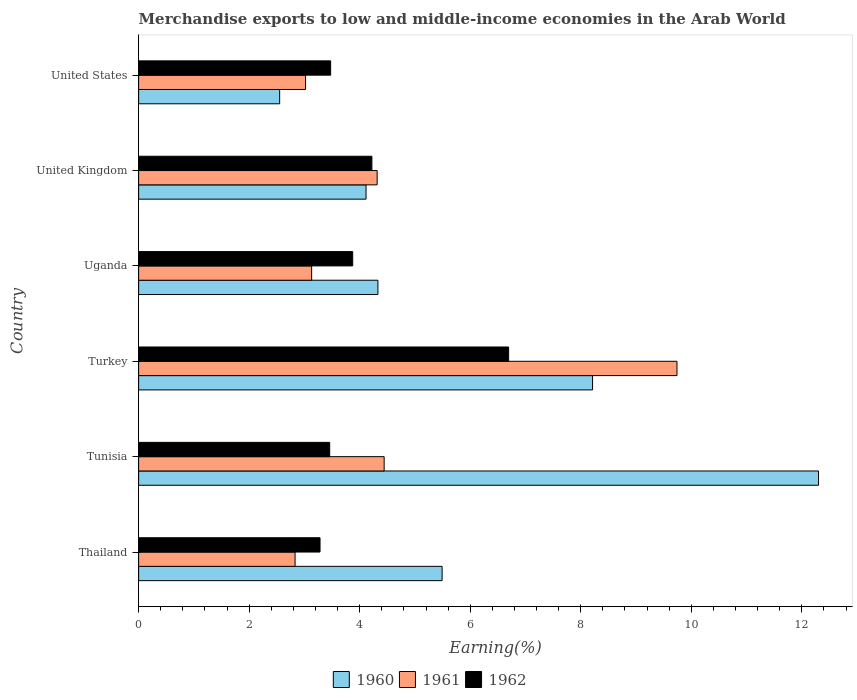How many bars are there on the 1st tick from the bottom?
Offer a very short reply. 3. What is the label of the 1st group of bars from the top?
Give a very brief answer. United States. In how many cases, is the number of bars for a given country not equal to the number of legend labels?
Make the answer very short. 0. What is the percentage of amount earned from merchandise exports in 1961 in United States?
Ensure brevity in your answer.  3.02. Across all countries, what is the maximum percentage of amount earned from merchandise exports in 1962?
Make the answer very short. 6.69. Across all countries, what is the minimum percentage of amount earned from merchandise exports in 1962?
Keep it short and to the point. 3.28. In which country was the percentage of amount earned from merchandise exports in 1960 maximum?
Your response must be concise. Tunisia. In which country was the percentage of amount earned from merchandise exports in 1960 minimum?
Provide a short and direct response. United States. What is the total percentage of amount earned from merchandise exports in 1960 in the graph?
Provide a short and direct response. 37. What is the difference between the percentage of amount earned from merchandise exports in 1961 in Tunisia and that in Turkey?
Give a very brief answer. -5.3. What is the difference between the percentage of amount earned from merchandise exports in 1962 in United Kingdom and the percentage of amount earned from merchandise exports in 1961 in United States?
Offer a very short reply. 1.2. What is the average percentage of amount earned from merchandise exports in 1961 per country?
Your response must be concise. 4.58. What is the difference between the percentage of amount earned from merchandise exports in 1962 and percentage of amount earned from merchandise exports in 1961 in United States?
Provide a succinct answer. 0.45. What is the ratio of the percentage of amount earned from merchandise exports in 1961 in Thailand to that in Turkey?
Provide a succinct answer. 0.29. Is the difference between the percentage of amount earned from merchandise exports in 1962 in United Kingdom and United States greater than the difference between the percentage of amount earned from merchandise exports in 1961 in United Kingdom and United States?
Make the answer very short. No. What is the difference between the highest and the second highest percentage of amount earned from merchandise exports in 1962?
Provide a succinct answer. 2.47. What is the difference between the highest and the lowest percentage of amount earned from merchandise exports in 1960?
Offer a terse response. 9.75. Is the sum of the percentage of amount earned from merchandise exports in 1961 in Turkey and United States greater than the maximum percentage of amount earned from merchandise exports in 1962 across all countries?
Keep it short and to the point. Yes. How many bars are there?
Keep it short and to the point. 18. Are all the bars in the graph horizontal?
Offer a terse response. Yes. How many countries are there in the graph?
Offer a very short reply. 6. Are the values on the major ticks of X-axis written in scientific E-notation?
Make the answer very short. No. Where does the legend appear in the graph?
Your response must be concise. Bottom center. How many legend labels are there?
Your response must be concise. 3. How are the legend labels stacked?
Make the answer very short. Horizontal. What is the title of the graph?
Offer a terse response. Merchandise exports to low and middle-income economies in the Arab World. Does "1979" appear as one of the legend labels in the graph?
Give a very brief answer. No. What is the label or title of the X-axis?
Provide a succinct answer. Earning(%). What is the label or title of the Y-axis?
Your response must be concise. Country. What is the Earning(%) in 1960 in Thailand?
Ensure brevity in your answer.  5.49. What is the Earning(%) in 1961 in Thailand?
Make the answer very short. 2.83. What is the Earning(%) in 1962 in Thailand?
Ensure brevity in your answer.  3.28. What is the Earning(%) of 1960 in Tunisia?
Give a very brief answer. 12.3. What is the Earning(%) in 1961 in Tunisia?
Ensure brevity in your answer.  4.44. What is the Earning(%) in 1962 in Tunisia?
Your answer should be very brief. 3.46. What is the Earning(%) in 1960 in Turkey?
Your response must be concise. 8.21. What is the Earning(%) in 1961 in Turkey?
Your answer should be very brief. 9.74. What is the Earning(%) of 1962 in Turkey?
Your answer should be very brief. 6.69. What is the Earning(%) of 1960 in Uganda?
Offer a terse response. 4.33. What is the Earning(%) in 1961 in Uganda?
Make the answer very short. 3.13. What is the Earning(%) in 1962 in Uganda?
Your answer should be very brief. 3.87. What is the Earning(%) in 1960 in United Kingdom?
Offer a terse response. 4.11. What is the Earning(%) in 1961 in United Kingdom?
Offer a very short reply. 4.32. What is the Earning(%) of 1962 in United Kingdom?
Offer a terse response. 4.22. What is the Earning(%) in 1960 in United States?
Offer a terse response. 2.55. What is the Earning(%) of 1961 in United States?
Your answer should be compact. 3.02. What is the Earning(%) of 1962 in United States?
Keep it short and to the point. 3.47. Across all countries, what is the maximum Earning(%) of 1960?
Your response must be concise. 12.3. Across all countries, what is the maximum Earning(%) in 1961?
Offer a terse response. 9.74. Across all countries, what is the maximum Earning(%) of 1962?
Ensure brevity in your answer.  6.69. Across all countries, what is the minimum Earning(%) of 1960?
Provide a short and direct response. 2.55. Across all countries, what is the minimum Earning(%) in 1961?
Your response must be concise. 2.83. Across all countries, what is the minimum Earning(%) in 1962?
Offer a very short reply. 3.28. What is the total Earning(%) of 1960 in the graph?
Make the answer very short. 37. What is the total Earning(%) in 1961 in the graph?
Make the answer very short. 27.48. What is the total Earning(%) in 1962 in the graph?
Offer a terse response. 25. What is the difference between the Earning(%) of 1960 in Thailand and that in Tunisia?
Offer a very short reply. -6.81. What is the difference between the Earning(%) of 1961 in Thailand and that in Tunisia?
Your answer should be compact. -1.61. What is the difference between the Earning(%) of 1962 in Thailand and that in Tunisia?
Make the answer very short. -0.18. What is the difference between the Earning(%) in 1960 in Thailand and that in Turkey?
Your answer should be compact. -2.72. What is the difference between the Earning(%) in 1961 in Thailand and that in Turkey?
Keep it short and to the point. -6.91. What is the difference between the Earning(%) in 1962 in Thailand and that in Turkey?
Give a very brief answer. -3.41. What is the difference between the Earning(%) in 1960 in Thailand and that in Uganda?
Your response must be concise. 1.16. What is the difference between the Earning(%) of 1961 in Thailand and that in Uganda?
Provide a short and direct response. -0.3. What is the difference between the Earning(%) in 1962 in Thailand and that in Uganda?
Your answer should be compact. -0.59. What is the difference between the Earning(%) in 1960 in Thailand and that in United Kingdom?
Make the answer very short. 1.38. What is the difference between the Earning(%) in 1961 in Thailand and that in United Kingdom?
Offer a very short reply. -1.49. What is the difference between the Earning(%) in 1962 in Thailand and that in United Kingdom?
Provide a short and direct response. -0.94. What is the difference between the Earning(%) of 1960 in Thailand and that in United States?
Keep it short and to the point. 2.94. What is the difference between the Earning(%) in 1961 in Thailand and that in United States?
Ensure brevity in your answer.  -0.19. What is the difference between the Earning(%) of 1962 in Thailand and that in United States?
Your answer should be very brief. -0.19. What is the difference between the Earning(%) of 1960 in Tunisia and that in Turkey?
Keep it short and to the point. 4.09. What is the difference between the Earning(%) of 1961 in Tunisia and that in Turkey?
Provide a succinct answer. -5.3. What is the difference between the Earning(%) in 1962 in Tunisia and that in Turkey?
Offer a terse response. -3.24. What is the difference between the Earning(%) of 1960 in Tunisia and that in Uganda?
Make the answer very short. 7.97. What is the difference between the Earning(%) of 1961 in Tunisia and that in Uganda?
Keep it short and to the point. 1.31. What is the difference between the Earning(%) in 1962 in Tunisia and that in Uganda?
Offer a very short reply. -0.42. What is the difference between the Earning(%) in 1960 in Tunisia and that in United Kingdom?
Provide a succinct answer. 8.19. What is the difference between the Earning(%) in 1961 in Tunisia and that in United Kingdom?
Provide a short and direct response. 0.13. What is the difference between the Earning(%) of 1962 in Tunisia and that in United Kingdom?
Ensure brevity in your answer.  -0.76. What is the difference between the Earning(%) of 1960 in Tunisia and that in United States?
Provide a succinct answer. 9.75. What is the difference between the Earning(%) of 1961 in Tunisia and that in United States?
Make the answer very short. 1.42. What is the difference between the Earning(%) of 1962 in Tunisia and that in United States?
Provide a short and direct response. -0.02. What is the difference between the Earning(%) in 1960 in Turkey and that in Uganda?
Your answer should be compact. 3.88. What is the difference between the Earning(%) of 1961 in Turkey and that in Uganda?
Ensure brevity in your answer.  6.61. What is the difference between the Earning(%) in 1962 in Turkey and that in Uganda?
Provide a short and direct response. 2.82. What is the difference between the Earning(%) in 1960 in Turkey and that in United Kingdom?
Keep it short and to the point. 4.1. What is the difference between the Earning(%) of 1961 in Turkey and that in United Kingdom?
Keep it short and to the point. 5.42. What is the difference between the Earning(%) in 1962 in Turkey and that in United Kingdom?
Offer a very short reply. 2.47. What is the difference between the Earning(%) of 1960 in Turkey and that in United States?
Make the answer very short. 5.66. What is the difference between the Earning(%) of 1961 in Turkey and that in United States?
Give a very brief answer. 6.72. What is the difference between the Earning(%) of 1962 in Turkey and that in United States?
Make the answer very short. 3.22. What is the difference between the Earning(%) in 1960 in Uganda and that in United Kingdom?
Provide a short and direct response. 0.21. What is the difference between the Earning(%) of 1961 in Uganda and that in United Kingdom?
Your answer should be compact. -1.19. What is the difference between the Earning(%) of 1962 in Uganda and that in United Kingdom?
Provide a short and direct response. -0.35. What is the difference between the Earning(%) in 1960 in Uganda and that in United States?
Ensure brevity in your answer.  1.78. What is the difference between the Earning(%) of 1961 in Uganda and that in United States?
Your answer should be very brief. 0.11. What is the difference between the Earning(%) in 1962 in Uganda and that in United States?
Provide a short and direct response. 0.4. What is the difference between the Earning(%) in 1960 in United Kingdom and that in United States?
Your answer should be compact. 1.56. What is the difference between the Earning(%) of 1961 in United Kingdom and that in United States?
Ensure brevity in your answer.  1.3. What is the difference between the Earning(%) of 1962 in United Kingdom and that in United States?
Give a very brief answer. 0.75. What is the difference between the Earning(%) in 1960 in Thailand and the Earning(%) in 1961 in Tunisia?
Provide a succinct answer. 1.05. What is the difference between the Earning(%) of 1960 in Thailand and the Earning(%) of 1962 in Tunisia?
Offer a very short reply. 2.03. What is the difference between the Earning(%) of 1961 in Thailand and the Earning(%) of 1962 in Tunisia?
Keep it short and to the point. -0.63. What is the difference between the Earning(%) in 1960 in Thailand and the Earning(%) in 1961 in Turkey?
Keep it short and to the point. -4.25. What is the difference between the Earning(%) in 1960 in Thailand and the Earning(%) in 1962 in Turkey?
Give a very brief answer. -1.2. What is the difference between the Earning(%) in 1961 in Thailand and the Earning(%) in 1962 in Turkey?
Keep it short and to the point. -3.86. What is the difference between the Earning(%) of 1960 in Thailand and the Earning(%) of 1961 in Uganda?
Give a very brief answer. 2.36. What is the difference between the Earning(%) of 1960 in Thailand and the Earning(%) of 1962 in Uganda?
Your response must be concise. 1.62. What is the difference between the Earning(%) of 1961 in Thailand and the Earning(%) of 1962 in Uganda?
Keep it short and to the point. -1.04. What is the difference between the Earning(%) in 1960 in Thailand and the Earning(%) in 1961 in United Kingdom?
Your answer should be very brief. 1.18. What is the difference between the Earning(%) in 1960 in Thailand and the Earning(%) in 1962 in United Kingdom?
Your answer should be compact. 1.27. What is the difference between the Earning(%) in 1961 in Thailand and the Earning(%) in 1962 in United Kingdom?
Keep it short and to the point. -1.39. What is the difference between the Earning(%) of 1960 in Thailand and the Earning(%) of 1961 in United States?
Give a very brief answer. 2.47. What is the difference between the Earning(%) of 1960 in Thailand and the Earning(%) of 1962 in United States?
Make the answer very short. 2.02. What is the difference between the Earning(%) of 1961 in Thailand and the Earning(%) of 1962 in United States?
Ensure brevity in your answer.  -0.64. What is the difference between the Earning(%) in 1960 in Tunisia and the Earning(%) in 1961 in Turkey?
Offer a terse response. 2.56. What is the difference between the Earning(%) in 1960 in Tunisia and the Earning(%) in 1962 in Turkey?
Your answer should be very brief. 5.61. What is the difference between the Earning(%) in 1961 in Tunisia and the Earning(%) in 1962 in Turkey?
Ensure brevity in your answer.  -2.25. What is the difference between the Earning(%) in 1960 in Tunisia and the Earning(%) in 1961 in Uganda?
Provide a short and direct response. 9.17. What is the difference between the Earning(%) of 1960 in Tunisia and the Earning(%) of 1962 in Uganda?
Make the answer very short. 8.43. What is the difference between the Earning(%) of 1961 in Tunisia and the Earning(%) of 1962 in Uganda?
Ensure brevity in your answer.  0.57. What is the difference between the Earning(%) of 1960 in Tunisia and the Earning(%) of 1961 in United Kingdom?
Make the answer very short. 7.99. What is the difference between the Earning(%) of 1960 in Tunisia and the Earning(%) of 1962 in United Kingdom?
Give a very brief answer. 8.08. What is the difference between the Earning(%) of 1961 in Tunisia and the Earning(%) of 1962 in United Kingdom?
Your answer should be compact. 0.22. What is the difference between the Earning(%) of 1960 in Tunisia and the Earning(%) of 1961 in United States?
Make the answer very short. 9.28. What is the difference between the Earning(%) of 1960 in Tunisia and the Earning(%) of 1962 in United States?
Ensure brevity in your answer.  8.83. What is the difference between the Earning(%) in 1961 in Tunisia and the Earning(%) in 1962 in United States?
Keep it short and to the point. 0.97. What is the difference between the Earning(%) of 1960 in Turkey and the Earning(%) of 1961 in Uganda?
Provide a succinct answer. 5.08. What is the difference between the Earning(%) in 1960 in Turkey and the Earning(%) in 1962 in Uganda?
Offer a terse response. 4.34. What is the difference between the Earning(%) in 1961 in Turkey and the Earning(%) in 1962 in Uganda?
Provide a succinct answer. 5.87. What is the difference between the Earning(%) of 1960 in Turkey and the Earning(%) of 1961 in United Kingdom?
Provide a succinct answer. 3.9. What is the difference between the Earning(%) of 1960 in Turkey and the Earning(%) of 1962 in United Kingdom?
Offer a very short reply. 3.99. What is the difference between the Earning(%) in 1961 in Turkey and the Earning(%) in 1962 in United Kingdom?
Give a very brief answer. 5.52. What is the difference between the Earning(%) in 1960 in Turkey and the Earning(%) in 1961 in United States?
Your answer should be very brief. 5.19. What is the difference between the Earning(%) in 1960 in Turkey and the Earning(%) in 1962 in United States?
Provide a short and direct response. 4.74. What is the difference between the Earning(%) in 1961 in Turkey and the Earning(%) in 1962 in United States?
Keep it short and to the point. 6.27. What is the difference between the Earning(%) of 1960 in Uganda and the Earning(%) of 1961 in United Kingdom?
Your response must be concise. 0.01. What is the difference between the Earning(%) in 1960 in Uganda and the Earning(%) in 1962 in United Kingdom?
Your answer should be compact. 0.11. What is the difference between the Earning(%) in 1961 in Uganda and the Earning(%) in 1962 in United Kingdom?
Make the answer very short. -1.09. What is the difference between the Earning(%) of 1960 in Uganda and the Earning(%) of 1961 in United States?
Your response must be concise. 1.31. What is the difference between the Earning(%) in 1960 in Uganda and the Earning(%) in 1962 in United States?
Offer a terse response. 0.86. What is the difference between the Earning(%) of 1961 in Uganda and the Earning(%) of 1962 in United States?
Ensure brevity in your answer.  -0.34. What is the difference between the Earning(%) in 1960 in United Kingdom and the Earning(%) in 1961 in United States?
Your answer should be very brief. 1.09. What is the difference between the Earning(%) of 1960 in United Kingdom and the Earning(%) of 1962 in United States?
Provide a short and direct response. 0.64. What is the difference between the Earning(%) of 1961 in United Kingdom and the Earning(%) of 1962 in United States?
Make the answer very short. 0.84. What is the average Earning(%) in 1960 per country?
Offer a very short reply. 6.17. What is the average Earning(%) in 1961 per country?
Provide a short and direct response. 4.58. What is the average Earning(%) of 1962 per country?
Your answer should be compact. 4.17. What is the difference between the Earning(%) in 1960 and Earning(%) in 1961 in Thailand?
Provide a short and direct response. 2.66. What is the difference between the Earning(%) of 1960 and Earning(%) of 1962 in Thailand?
Offer a very short reply. 2.21. What is the difference between the Earning(%) in 1961 and Earning(%) in 1962 in Thailand?
Provide a short and direct response. -0.45. What is the difference between the Earning(%) of 1960 and Earning(%) of 1961 in Tunisia?
Make the answer very short. 7.86. What is the difference between the Earning(%) in 1960 and Earning(%) in 1962 in Tunisia?
Ensure brevity in your answer.  8.84. What is the difference between the Earning(%) in 1961 and Earning(%) in 1962 in Tunisia?
Your answer should be compact. 0.99. What is the difference between the Earning(%) of 1960 and Earning(%) of 1961 in Turkey?
Offer a terse response. -1.53. What is the difference between the Earning(%) of 1960 and Earning(%) of 1962 in Turkey?
Offer a very short reply. 1.52. What is the difference between the Earning(%) in 1961 and Earning(%) in 1962 in Turkey?
Provide a succinct answer. 3.05. What is the difference between the Earning(%) in 1960 and Earning(%) in 1961 in Uganda?
Keep it short and to the point. 1.2. What is the difference between the Earning(%) of 1960 and Earning(%) of 1962 in Uganda?
Give a very brief answer. 0.46. What is the difference between the Earning(%) of 1961 and Earning(%) of 1962 in Uganda?
Ensure brevity in your answer.  -0.74. What is the difference between the Earning(%) in 1960 and Earning(%) in 1961 in United Kingdom?
Your answer should be very brief. -0.2. What is the difference between the Earning(%) of 1960 and Earning(%) of 1962 in United Kingdom?
Your response must be concise. -0.11. What is the difference between the Earning(%) in 1961 and Earning(%) in 1962 in United Kingdom?
Offer a very short reply. 0.1. What is the difference between the Earning(%) in 1960 and Earning(%) in 1961 in United States?
Provide a succinct answer. -0.47. What is the difference between the Earning(%) of 1960 and Earning(%) of 1962 in United States?
Your answer should be very brief. -0.92. What is the difference between the Earning(%) in 1961 and Earning(%) in 1962 in United States?
Ensure brevity in your answer.  -0.45. What is the ratio of the Earning(%) of 1960 in Thailand to that in Tunisia?
Provide a short and direct response. 0.45. What is the ratio of the Earning(%) in 1961 in Thailand to that in Tunisia?
Ensure brevity in your answer.  0.64. What is the ratio of the Earning(%) of 1962 in Thailand to that in Tunisia?
Offer a terse response. 0.95. What is the ratio of the Earning(%) in 1960 in Thailand to that in Turkey?
Make the answer very short. 0.67. What is the ratio of the Earning(%) of 1961 in Thailand to that in Turkey?
Provide a succinct answer. 0.29. What is the ratio of the Earning(%) in 1962 in Thailand to that in Turkey?
Make the answer very short. 0.49. What is the ratio of the Earning(%) in 1960 in Thailand to that in Uganda?
Give a very brief answer. 1.27. What is the ratio of the Earning(%) in 1961 in Thailand to that in Uganda?
Your answer should be compact. 0.9. What is the ratio of the Earning(%) in 1962 in Thailand to that in Uganda?
Make the answer very short. 0.85. What is the ratio of the Earning(%) in 1960 in Thailand to that in United Kingdom?
Keep it short and to the point. 1.33. What is the ratio of the Earning(%) in 1961 in Thailand to that in United Kingdom?
Provide a short and direct response. 0.66. What is the ratio of the Earning(%) in 1962 in Thailand to that in United Kingdom?
Offer a very short reply. 0.78. What is the ratio of the Earning(%) in 1960 in Thailand to that in United States?
Offer a terse response. 2.15. What is the ratio of the Earning(%) in 1961 in Thailand to that in United States?
Your answer should be compact. 0.94. What is the ratio of the Earning(%) in 1962 in Thailand to that in United States?
Offer a terse response. 0.94. What is the ratio of the Earning(%) of 1960 in Tunisia to that in Turkey?
Keep it short and to the point. 1.5. What is the ratio of the Earning(%) in 1961 in Tunisia to that in Turkey?
Make the answer very short. 0.46. What is the ratio of the Earning(%) in 1962 in Tunisia to that in Turkey?
Provide a short and direct response. 0.52. What is the ratio of the Earning(%) of 1960 in Tunisia to that in Uganda?
Give a very brief answer. 2.84. What is the ratio of the Earning(%) in 1961 in Tunisia to that in Uganda?
Your answer should be compact. 1.42. What is the ratio of the Earning(%) in 1962 in Tunisia to that in Uganda?
Make the answer very short. 0.89. What is the ratio of the Earning(%) in 1960 in Tunisia to that in United Kingdom?
Ensure brevity in your answer.  2.99. What is the ratio of the Earning(%) of 1961 in Tunisia to that in United Kingdom?
Give a very brief answer. 1.03. What is the ratio of the Earning(%) in 1962 in Tunisia to that in United Kingdom?
Give a very brief answer. 0.82. What is the ratio of the Earning(%) in 1960 in Tunisia to that in United States?
Offer a very short reply. 4.82. What is the ratio of the Earning(%) of 1961 in Tunisia to that in United States?
Your response must be concise. 1.47. What is the ratio of the Earning(%) in 1962 in Tunisia to that in United States?
Offer a very short reply. 1. What is the ratio of the Earning(%) in 1960 in Turkey to that in Uganda?
Keep it short and to the point. 1.9. What is the ratio of the Earning(%) of 1961 in Turkey to that in Uganda?
Offer a terse response. 3.11. What is the ratio of the Earning(%) of 1962 in Turkey to that in Uganda?
Keep it short and to the point. 1.73. What is the ratio of the Earning(%) in 1960 in Turkey to that in United Kingdom?
Your response must be concise. 2. What is the ratio of the Earning(%) of 1961 in Turkey to that in United Kingdom?
Make the answer very short. 2.26. What is the ratio of the Earning(%) in 1962 in Turkey to that in United Kingdom?
Your response must be concise. 1.59. What is the ratio of the Earning(%) of 1960 in Turkey to that in United States?
Your answer should be compact. 3.22. What is the ratio of the Earning(%) of 1961 in Turkey to that in United States?
Give a very brief answer. 3.23. What is the ratio of the Earning(%) of 1962 in Turkey to that in United States?
Give a very brief answer. 1.93. What is the ratio of the Earning(%) in 1960 in Uganda to that in United Kingdom?
Provide a short and direct response. 1.05. What is the ratio of the Earning(%) of 1961 in Uganda to that in United Kingdom?
Provide a short and direct response. 0.73. What is the ratio of the Earning(%) of 1962 in Uganda to that in United Kingdom?
Your answer should be compact. 0.92. What is the ratio of the Earning(%) in 1960 in Uganda to that in United States?
Your answer should be very brief. 1.7. What is the ratio of the Earning(%) of 1961 in Uganda to that in United States?
Provide a short and direct response. 1.04. What is the ratio of the Earning(%) of 1962 in Uganda to that in United States?
Your answer should be compact. 1.11. What is the ratio of the Earning(%) in 1960 in United Kingdom to that in United States?
Your answer should be compact. 1.61. What is the ratio of the Earning(%) in 1961 in United Kingdom to that in United States?
Your answer should be very brief. 1.43. What is the ratio of the Earning(%) in 1962 in United Kingdom to that in United States?
Offer a terse response. 1.21. What is the difference between the highest and the second highest Earning(%) in 1960?
Give a very brief answer. 4.09. What is the difference between the highest and the second highest Earning(%) in 1961?
Give a very brief answer. 5.3. What is the difference between the highest and the second highest Earning(%) in 1962?
Keep it short and to the point. 2.47. What is the difference between the highest and the lowest Earning(%) in 1960?
Provide a succinct answer. 9.75. What is the difference between the highest and the lowest Earning(%) in 1961?
Your answer should be compact. 6.91. What is the difference between the highest and the lowest Earning(%) in 1962?
Ensure brevity in your answer.  3.41. 